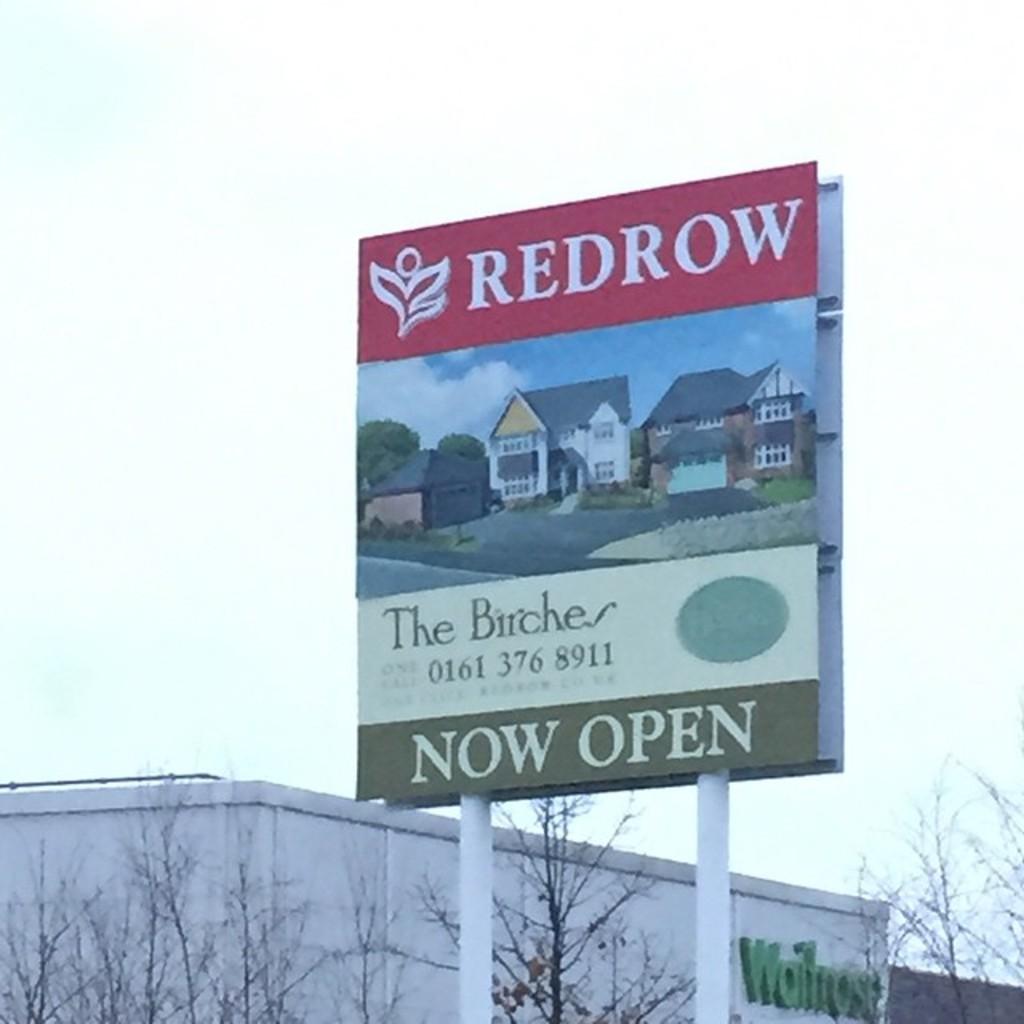What is the phone number on the sign?
Make the answer very short. 0161 376 8911. What  place is the sign advertising?
Make the answer very short. The birches. 